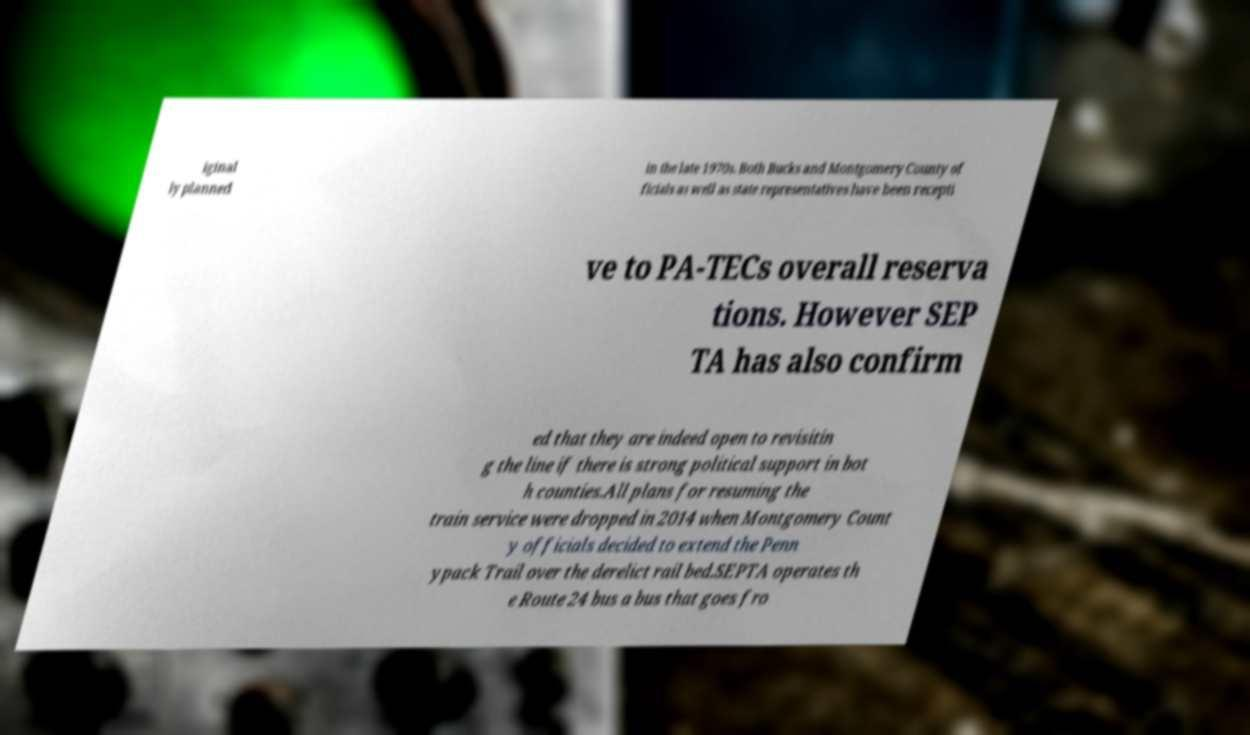Please read and relay the text visible in this image. What does it say? iginal ly planned in the late 1970s. Both Bucks and Montgomery County of ficials as well as state representatives have been recepti ve to PA-TECs overall reserva tions. However SEP TA has also confirm ed that they are indeed open to revisitin g the line if there is strong political support in bot h counties.All plans for resuming the train service were dropped in 2014 when Montgomery Count y officials decided to extend the Penn ypack Trail over the derelict rail bed.SEPTA operates th e Route 24 bus a bus that goes fro 